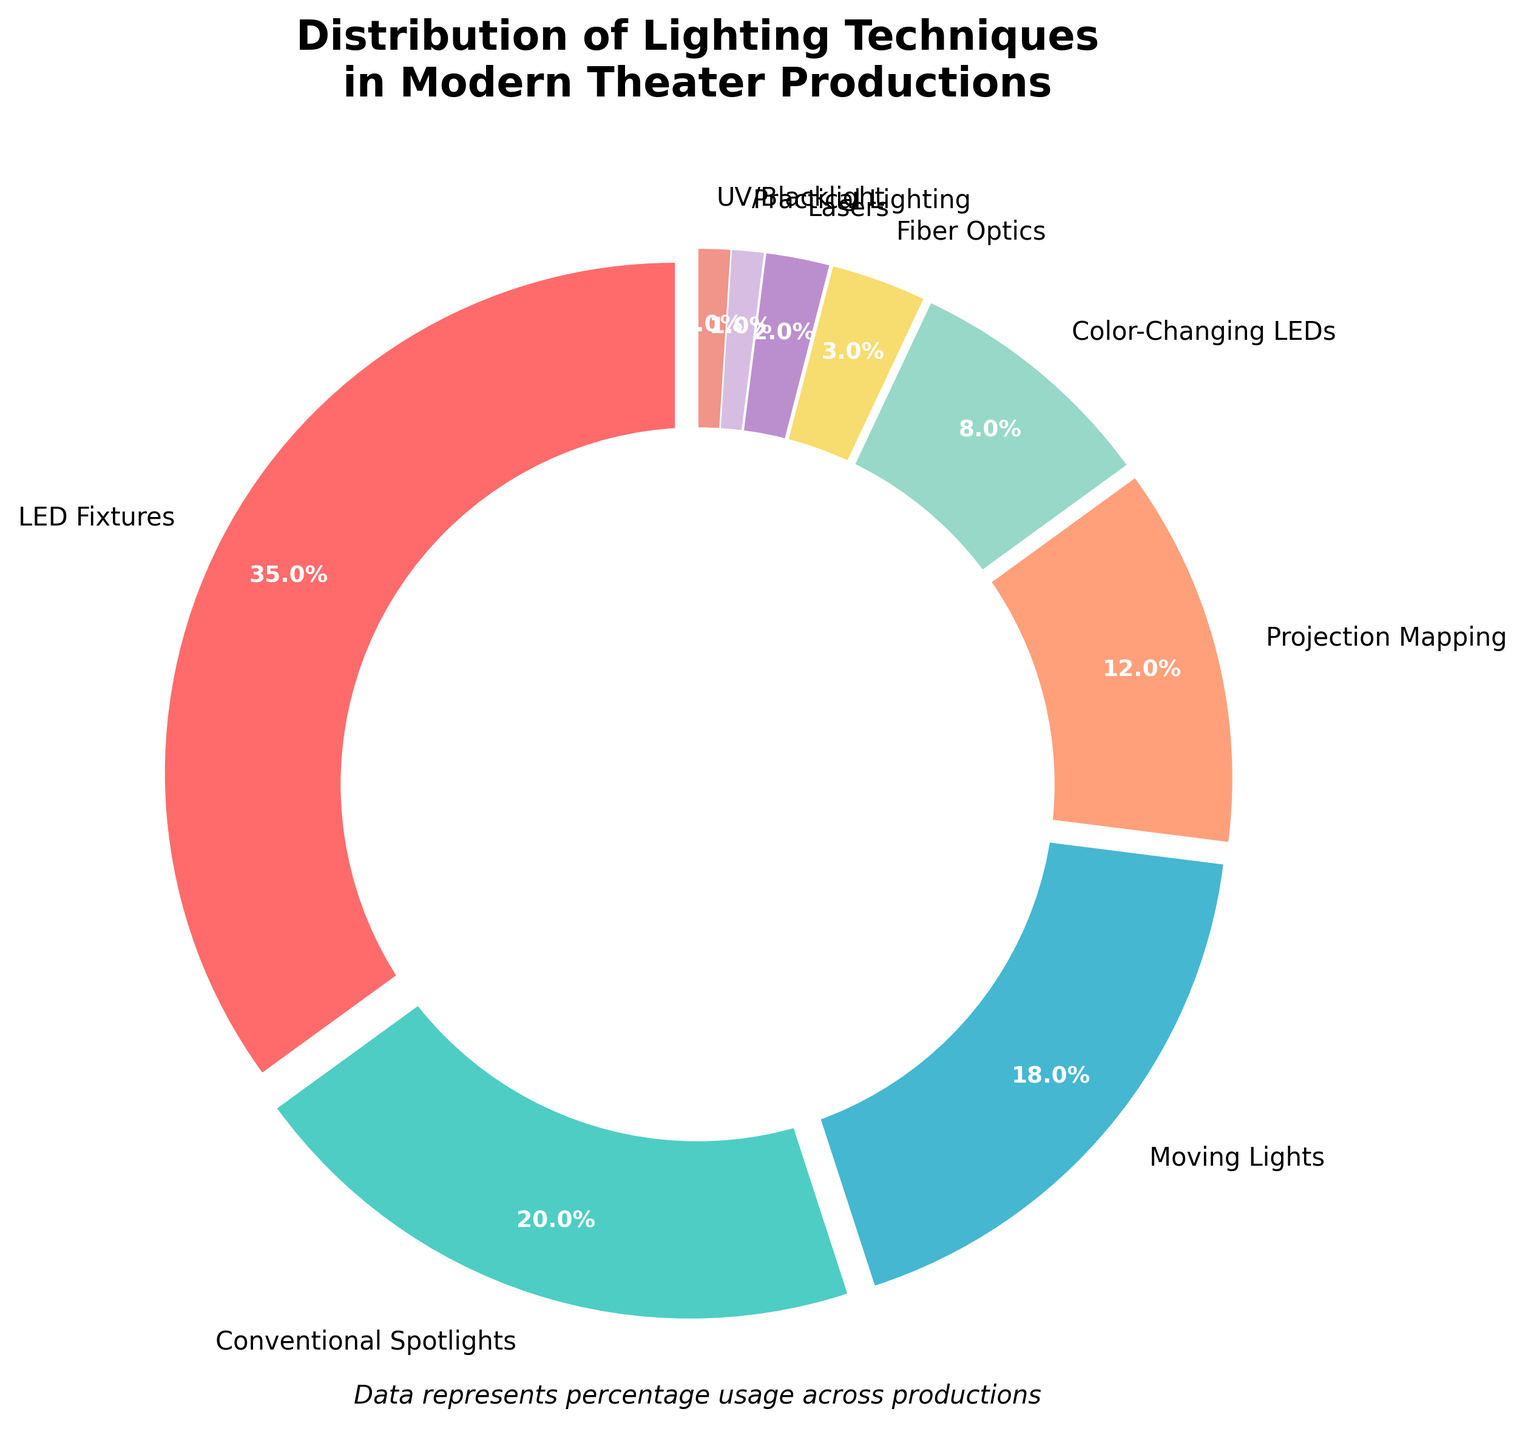Which lighting technique is used the most in modern theater productions? The largest segment in the pie chart represents the most used technique. The slice labeled "LED Fixtures" is the largest, covering 35% of the chart.
Answer: LED Fixtures Which two lighting techniques together account for more than 50% of usage in modern theater productions? To find this, add the percentages of the two highest values from the pie chart. LED Fixtures (35%) + Conventional Spotlights (20%) = 55%.
Answer: LED Fixtures and Conventional Spotlights What is the combined percentage of Moving Lights and Projection Mapping techniques? Add the percentages of Moving Lights (18%) and Projection Mapping (12%). 18% + 12% = 30%.
Answer: 30% How does the use of Color-Changing LEDs compare to Fiber Optics? Compare the percentages directly from the pie chart. Color-Changing LEDs account for 8%, while Fiber Optics account for 3%. 8% is greater than 3%.
Answer: Color-Changing LEDs are used more than Fiber Optics What is the percentage difference between Conventional Spotlights and Practical Lighting? Subtract the percentage of Practical Lighting from Conventional Spotlights. 20% - 1% = 19%.
Answer: 19% Which lighting techniques have the smallest usage, and what are their combined percentage? Identify the smallest segments in the pie chart. Practical Lighting (1%) and UV/Blacklight (1%) are the smallest. Their combined percentage is 1% + 1% = 2%.
Answer: Practical Lighting and UV/Blacklight, 2% Which lighting technique accounts for a single-digit percentage and is not the least used? From the pie chart, Color-Changing LEDs account for 8%, which is in single digits but not the least used.
Answer: Color-Changing LEDs If the total production count is 200, how many productions use Lasers? Calculate the number based on the percentage. 2% of 200 productions = 0.02 * 200 = 4 productions.
Answer: 4 What is the combined percentage of all lighting techniques that are used less than 10% each? Sum the percentages of Fiber Optics (3%), Lasers (2%), Practical Lighting (1%), and UV/Blacklight (1%). 3% + 2% + 1% + 1% = 7%.
Answer: 7% What percentage of the chart is represented by techniques other than LED Fixtures and Conventional Spotlights? Subtract the combined percentage of LED Fixtures and Conventional Spotlights from 100%. 100% - (35% + 20%) = 45%.
Answer: 45% 